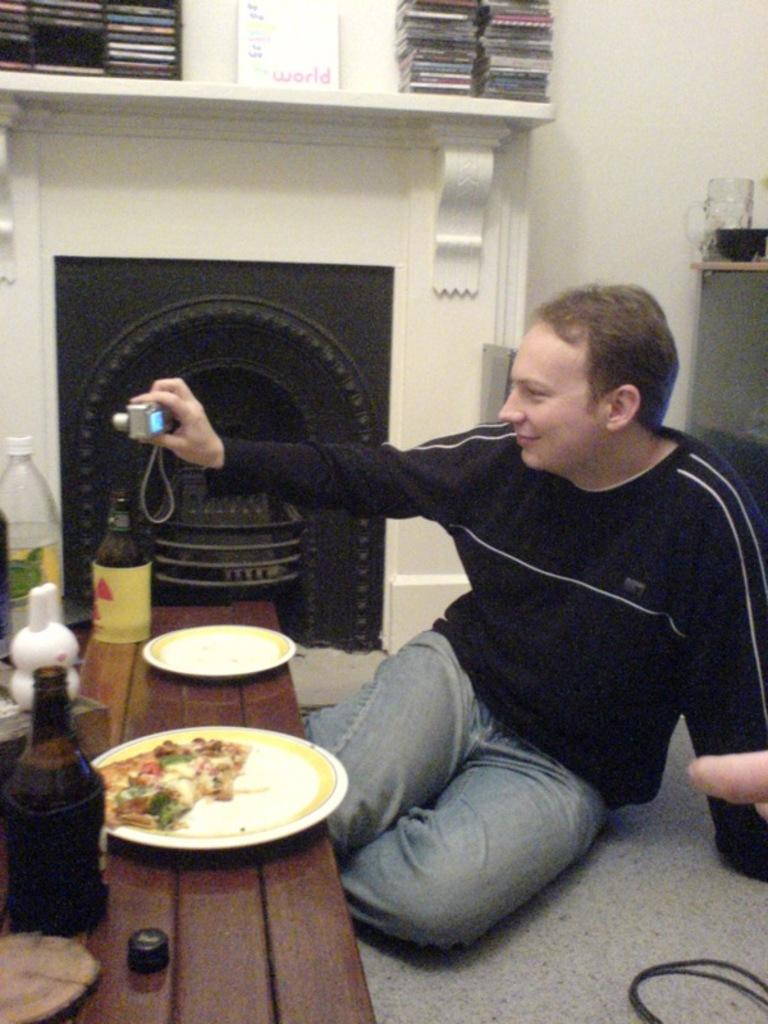<image>
Write a terse but informative summary of the picture. A man by a fireplace with paper that says "World" on it. 